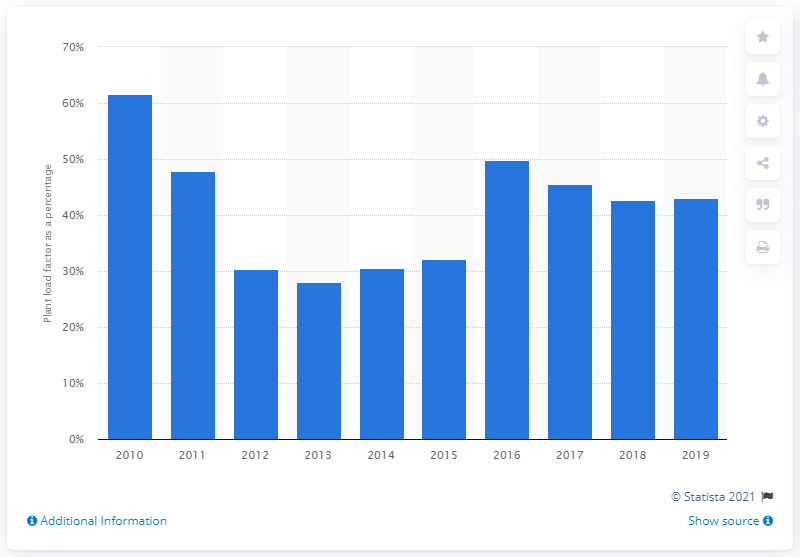Identify some key points in this picture. The load factor of combined cycle gas turbine stations in the UK began to fluctuate in 2010. In 2019, the performance loss factor of combined cycle gas turbine stations was 43%. 